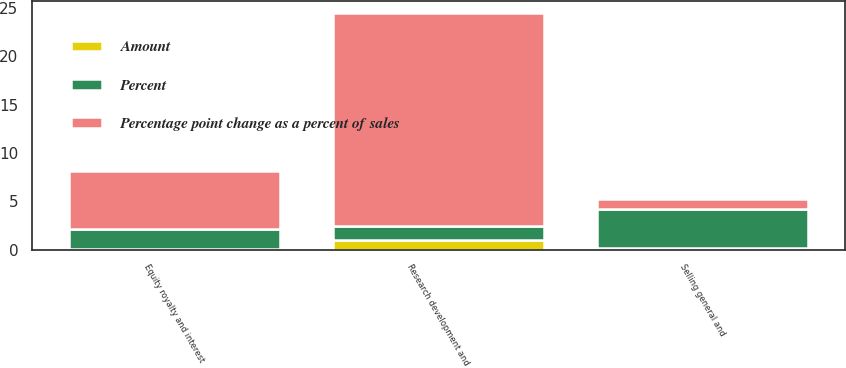Convert chart. <chart><loc_0><loc_0><loc_500><loc_500><stacked_bar_chart><ecel><fcel>Selling general and<fcel>Research development and<fcel>Equity royalty and interest<nl><fcel>Percent<fcel>4<fcel>1.5<fcel>2<nl><fcel>Percentage point change as a percent of sales<fcel>1<fcel>22<fcel>6<nl><fcel>Amount<fcel>0.2<fcel>1<fcel>0.1<nl></chart> 